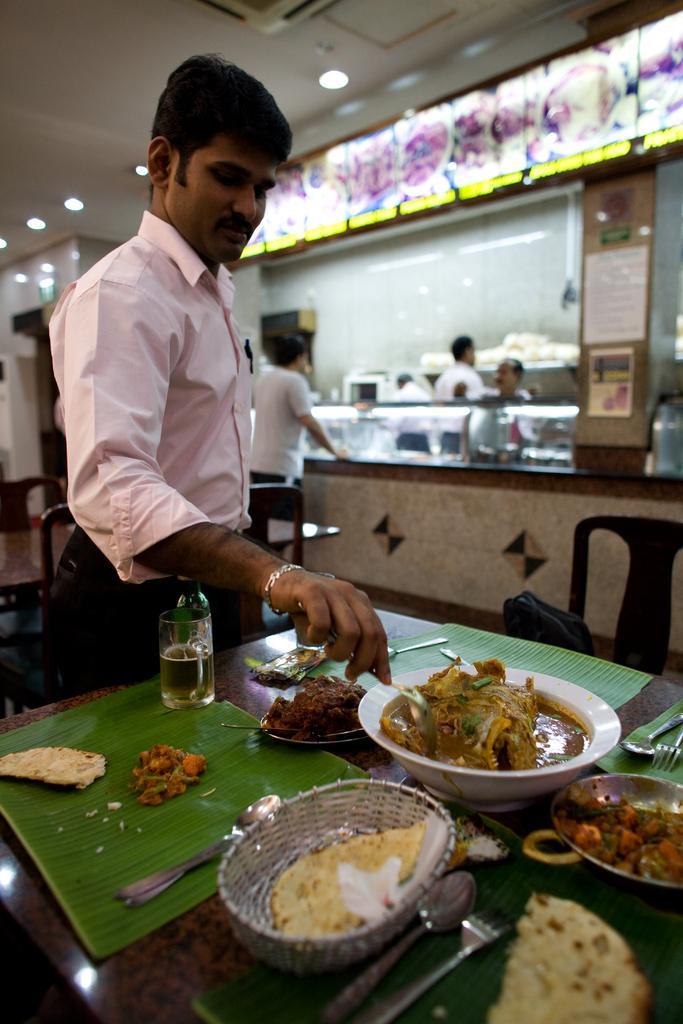Could you give a brief overview of what you see in this image? This image is taken indoors. At the bottom of the image there is a table with many food items and a few things on it. In the middle of the image a man is standing on the floor and he is serving food. In the background there is a wall with many boards and text on them and there are a few empty chairs and a table. Three men are standing on the floor. At the top of the image there is a ceiling with lights. 